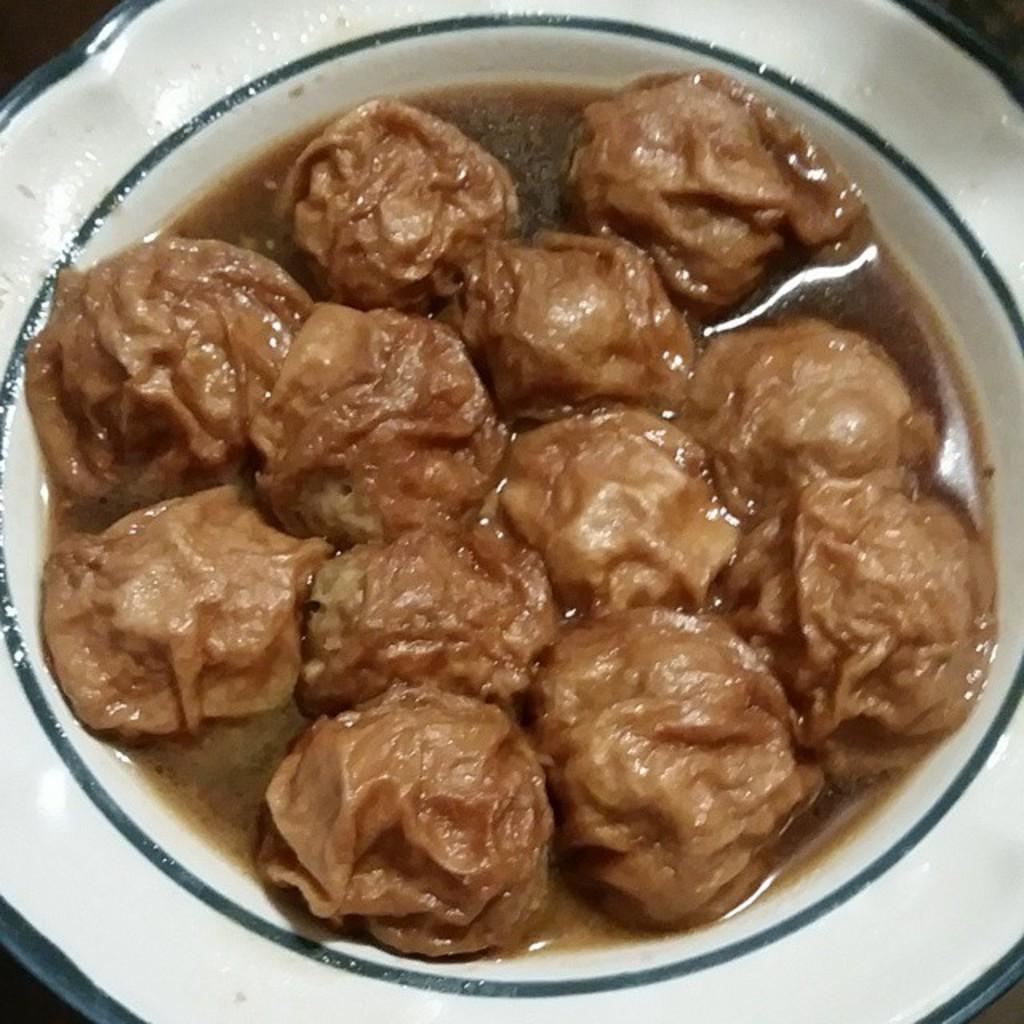What is located in the center of the image? There is a plate in the center of the image. What is on the plate? There is a food item on the plate. What type of guide can be seen walking through the alley in the image? There is no guide or alley present in the image; it only features a plate with a food item on it. 